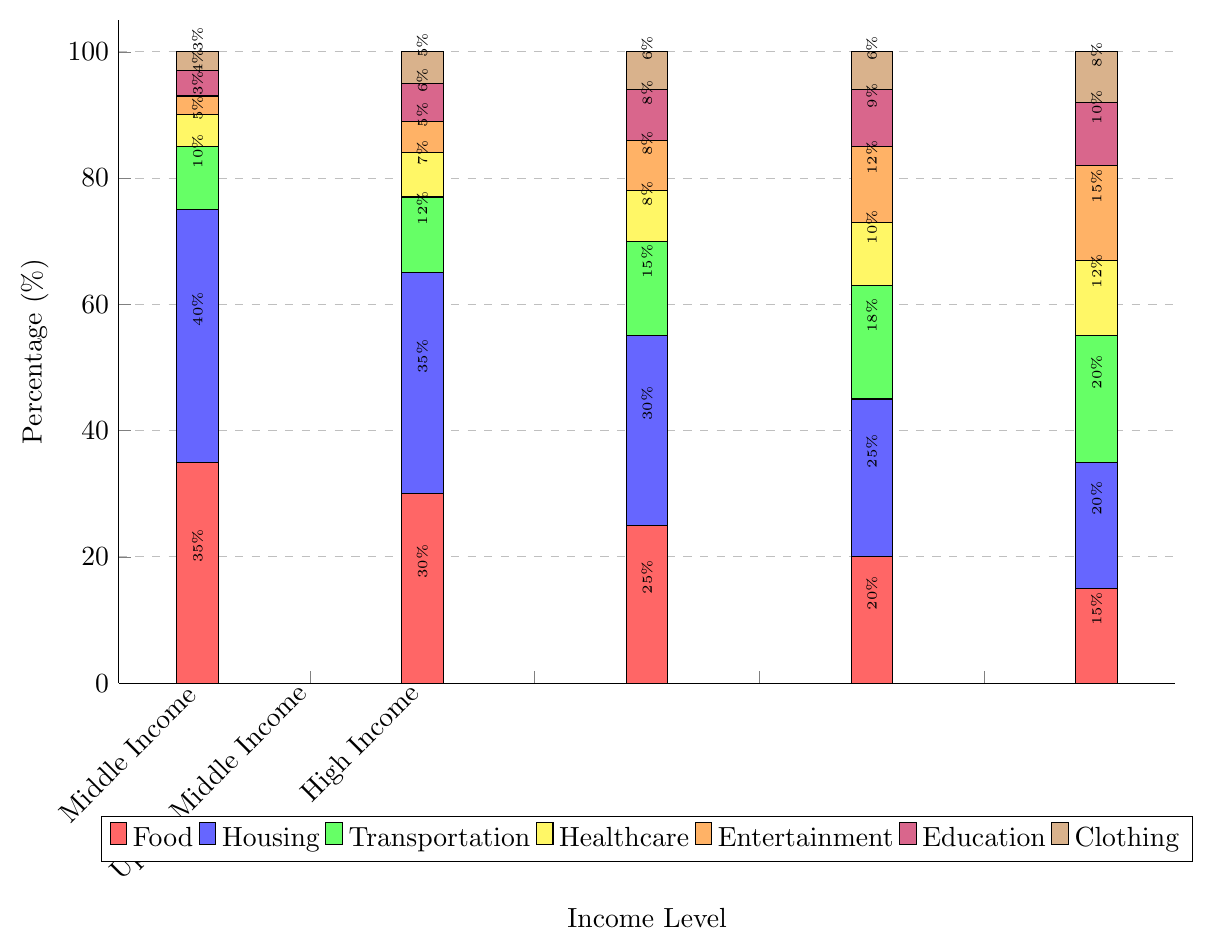How does the percentage spending on food differ between Low Income and High Income groups? By looking at the red bars in the chart, you can see that the percentage for Low Income is 35% while for High Income, it is 15%. The difference is calculated as 35% - 15%.
Answer: 20% Which income group spends the most on healthcare? The highest segment of the yellow bars represents healthcare spending. The tallest yellow bar is for the High Income group, which indicates that they spend the most on healthcare.
Answer: High Income Compare the total percentage spending on education and entertainment for the Upper Middle Income group. For the Upper Middle Income group, the green bar (education) is 9% and the orange bar (entertainment) is 12%. Adding these percentages gives 9% + 12%.
Answer: 21% What is the total percentage of spending on housing across all income levels? Sum the percentages of the blue bars for all the income groups: 40% (Low Income) + 35% (Lower Middle Income) + 30% (Middle Income) + 25% (Upper Middle Income) + 20% (High Income) = 150%.
Answer: 150% Between which two income groups is the difference in clothing spending the smallest? By comparing the brown bars, observe the values: 3% (Low Income), 5% (Lower Middle Income), 6% (Middle Income), 6% (Upper Middle Income), 8% (High Income). The smallest difference occurs between Middle Income and Upper Middle Income, both at 6%.
Answer: Middle Income and Upper Middle Income What is the average spending on transportation for all income levels? The green bar values for each income group need to be averaged: (10% (Low Income) + 12% (Lower Middle Income) + 15% (Middle Income) + 18% (Upper Middle Income) + 20% (High Income)) / 5 = 75% / 5.
Answer: 15% Which expense category has the highest total percentage across all income levels? By summing the percentages of each color bar for all groups: Red (Food) total = 35 + 30 + 25 + 20 + 15 = 125, Blue (Housing) total = 40 + 35 + 30 + 25 + 20 = 150, Green (Transportation) total = 10 + 12 + 15 + 18 + 20 = 75, Yellow (Healthcare) total = 5 + 7 + 8 + 10 + 12 = 42, Orange (Entertainment) total = 3 + 5 + 8 + 12 + 15 = 43, Purple (Education) total = 4 + 6 + 8 + 9 + 10 = 37, Brown (Clothing) total = 3 + 5 + 6 + 6 + 8 = 28. Housing has the highest total with 150%.
Answer: Housing 